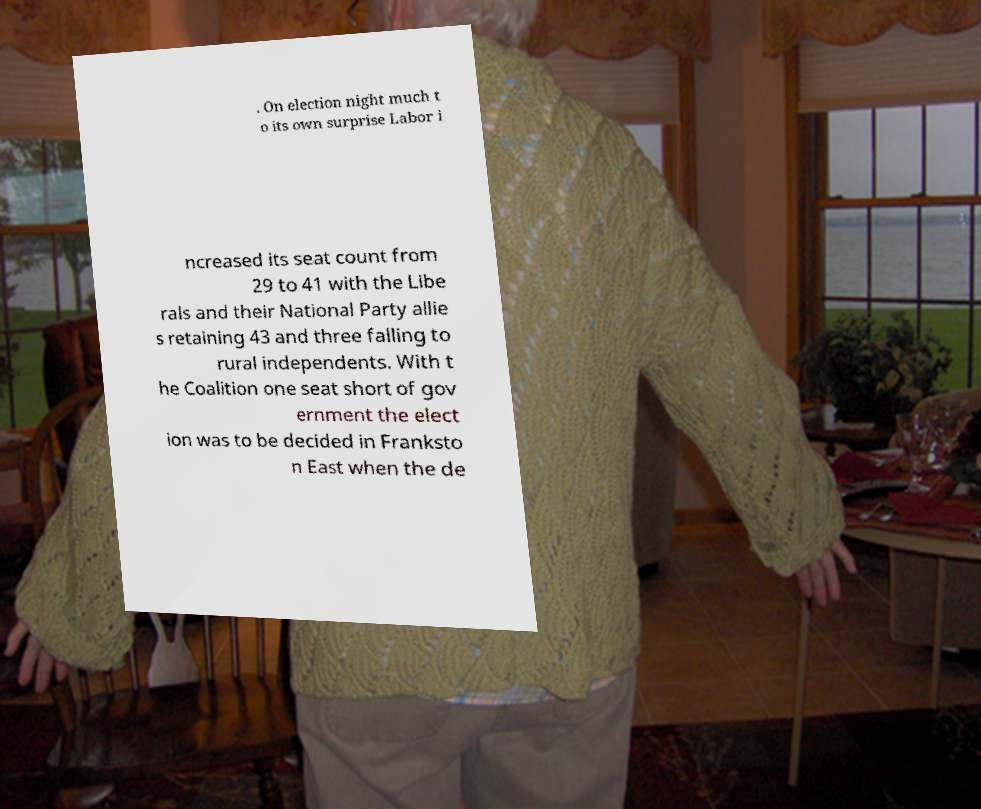Could you extract and type out the text from this image? . On election night much t o its own surprise Labor i ncreased its seat count from 29 to 41 with the Libe rals and their National Party allie s retaining 43 and three falling to rural independents. With t he Coalition one seat short of gov ernment the elect ion was to be decided in Franksto n East when the de 